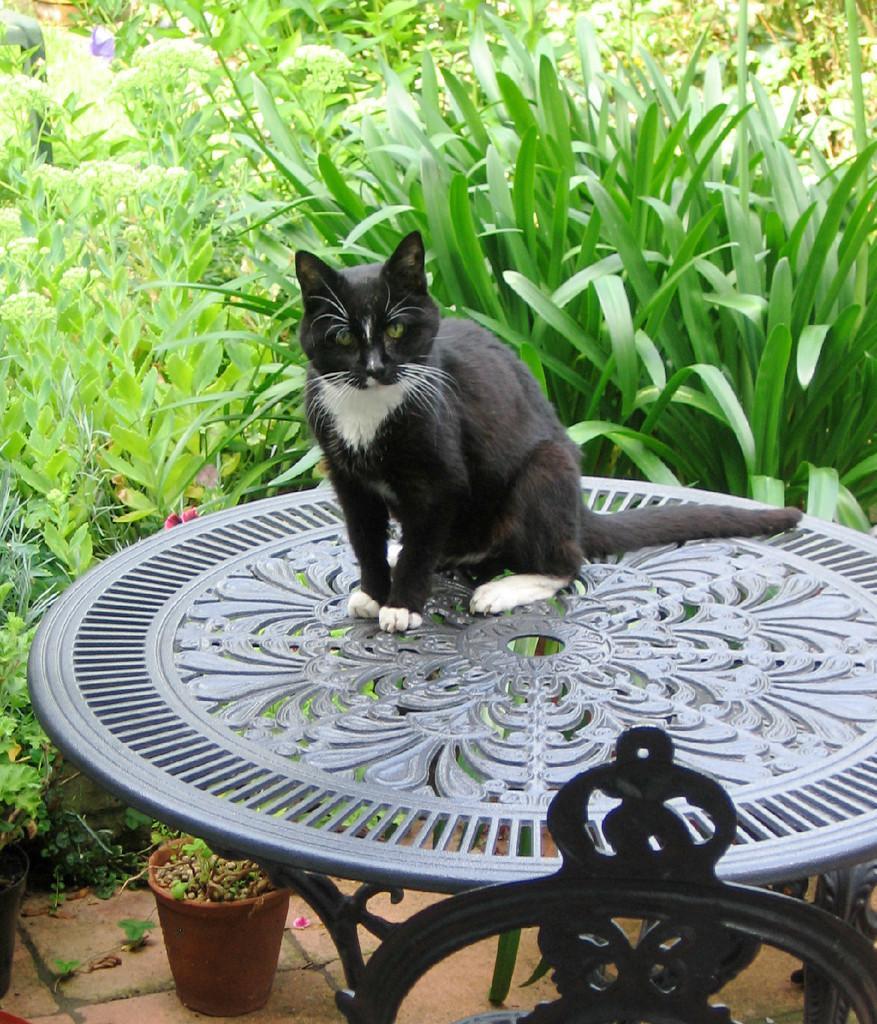In one or two sentences, can you explain what this image depicts? In this picture there is a cat on the table and there are trees around the area of the image, the cat is black in color. 